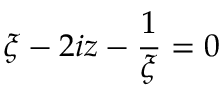Convert formula to latex. <formula><loc_0><loc_0><loc_500><loc_500>{ \xi - 2 i z - { \frac { 1 } { \xi } } } = 0</formula> 